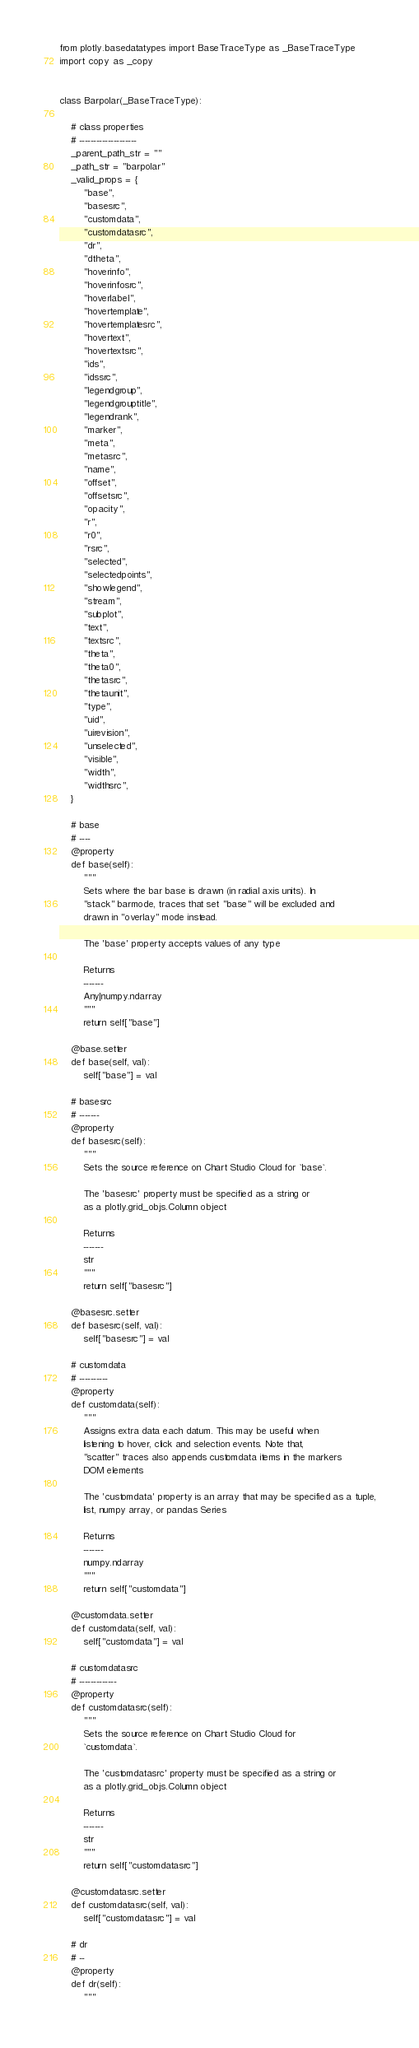<code> <loc_0><loc_0><loc_500><loc_500><_Python_>from plotly.basedatatypes import BaseTraceType as _BaseTraceType
import copy as _copy


class Barpolar(_BaseTraceType):

    # class properties
    # --------------------
    _parent_path_str = ""
    _path_str = "barpolar"
    _valid_props = {
        "base",
        "basesrc",
        "customdata",
        "customdatasrc",
        "dr",
        "dtheta",
        "hoverinfo",
        "hoverinfosrc",
        "hoverlabel",
        "hovertemplate",
        "hovertemplatesrc",
        "hovertext",
        "hovertextsrc",
        "ids",
        "idssrc",
        "legendgroup",
        "legendgrouptitle",
        "legendrank",
        "marker",
        "meta",
        "metasrc",
        "name",
        "offset",
        "offsetsrc",
        "opacity",
        "r",
        "r0",
        "rsrc",
        "selected",
        "selectedpoints",
        "showlegend",
        "stream",
        "subplot",
        "text",
        "textsrc",
        "theta",
        "theta0",
        "thetasrc",
        "thetaunit",
        "type",
        "uid",
        "uirevision",
        "unselected",
        "visible",
        "width",
        "widthsrc",
    }

    # base
    # ----
    @property
    def base(self):
        """
        Sets where the bar base is drawn (in radial axis units). In
        "stack" barmode, traces that set "base" will be excluded and
        drawn in "overlay" mode instead.

        The 'base' property accepts values of any type

        Returns
        -------
        Any|numpy.ndarray
        """
        return self["base"]

    @base.setter
    def base(self, val):
        self["base"] = val

    # basesrc
    # -------
    @property
    def basesrc(self):
        """
        Sets the source reference on Chart Studio Cloud for `base`.

        The 'basesrc' property must be specified as a string or
        as a plotly.grid_objs.Column object

        Returns
        -------
        str
        """
        return self["basesrc"]

    @basesrc.setter
    def basesrc(self, val):
        self["basesrc"] = val

    # customdata
    # ----------
    @property
    def customdata(self):
        """
        Assigns extra data each datum. This may be useful when
        listening to hover, click and selection events. Note that,
        "scatter" traces also appends customdata items in the markers
        DOM elements

        The 'customdata' property is an array that may be specified as a tuple,
        list, numpy array, or pandas Series

        Returns
        -------
        numpy.ndarray
        """
        return self["customdata"]

    @customdata.setter
    def customdata(self, val):
        self["customdata"] = val

    # customdatasrc
    # -------------
    @property
    def customdatasrc(self):
        """
        Sets the source reference on Chart Studio Cloud for
        `customdata`.

        The 'customdatasrc' property must be specified as a string or
        as a plotly.grid_objs.Column object

        Returns
        -------
        str
        """
        return self["customdatasrc"]

    @customdatasrc.setter
    def customdatasrc(self, val):
        self["customdatasrc"] = val

    # dr
    # --
    @property
    def dr(self):
        """</code> 